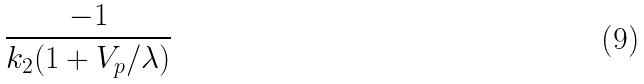Convert formula to latex. <formula><loc_0><loc_0><loc_500><loc_500>\frac { - 1 } { k _ { 2 } ( 1 + V _ { p } / \lambda ) }</formula> 